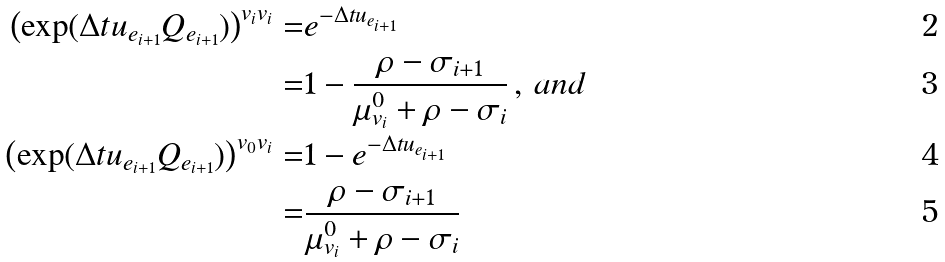<formula> <loc_0><loc_0><loc_500><loc_500>\left ( \exp ( \Delta t u _ { e _ { i + 1 } } Q _ { e _ { i + 1 } } ) \right ) ^ { v _ { i } v _ { i } } = & e ^ { - \Delta t u _ { e _ { i + 1 } } } \\ = & 1 - \frac { \rho - \sigma _ { i + 1 } } { \mu ^ { 0 } _ { v _ { i } } + \rho - \sigma _ { i } } \, , \, a n d \\ \left ( \exp ( \Delta t u _ { e _ { i + 1 } } Q _ { e _ { i + 1 } } ) \right ) ^ { v _ { 0 } v _ { i } } = & 1 - e ^ { - \Delta t u _ { e _ { i + 1 } } } \\ = & \frac { \rho - \sigma _ { i + 1 } } { \mu ^ { 0 } _ { v _ { i } } + \rho - \sigma _ { i } }</formula> 